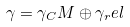<formula> <loc_0><loc_0><loc_500><loc_500>\gamma = \gamma _ { C } M \oplus \gamma _ { r } e l</formula> 